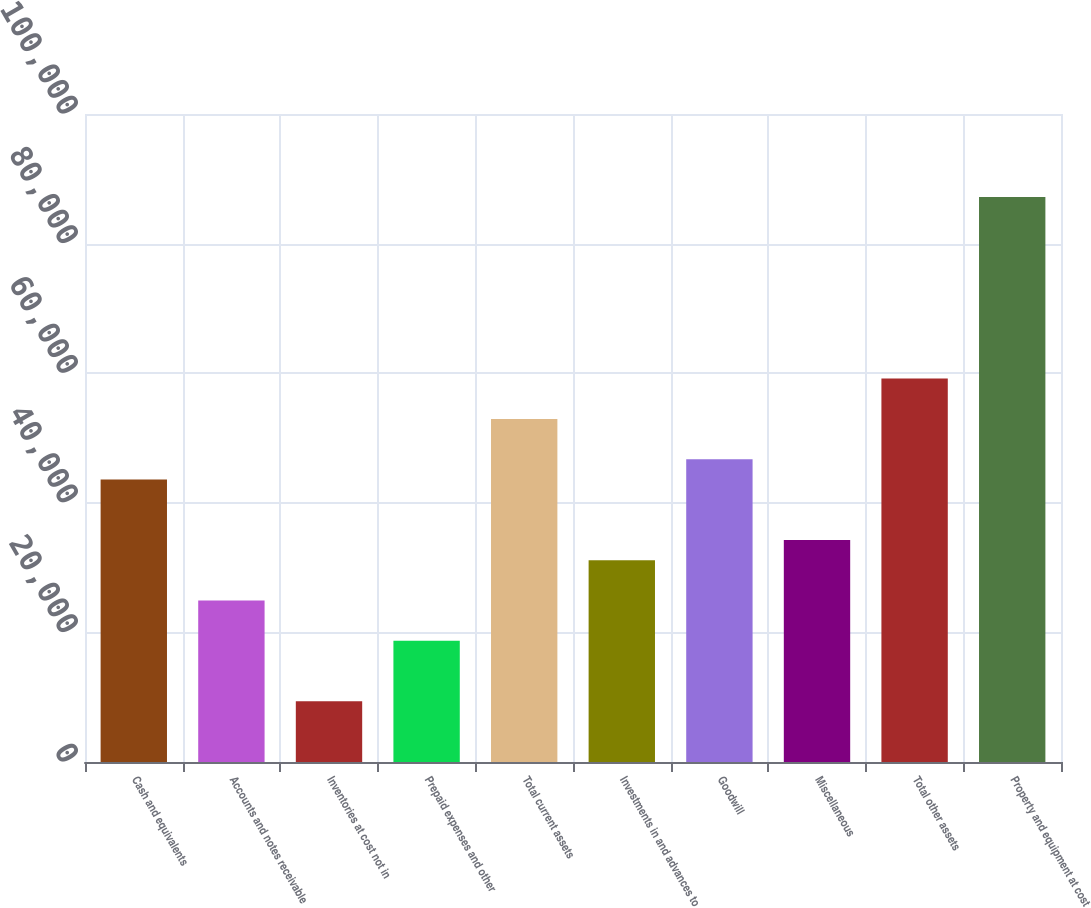<chart> <loc_0><loc_0><loc_500><loc_500><bar_chart><fcel>Cash and equivalents<fcel>Accounts and notes receivable<fcel>Inventories at cost not in<fcel>Prepaid expenses and other<fcel>Total current assets<fcel>Investments in and advances to<fcel>Goodwill<fcel>Miscellaneous<fcel>Total other assets<fcel>Property and equipment at cost<nl><fcel>43606.7<fcel>24925.2<fcel>9357.34<fcel>18698.1<fcel>52947.5<fcel>31152.4<fcel>46720.3<fcel>34266<fcel>59174.6<fcel>87196.8<nl></chart> 